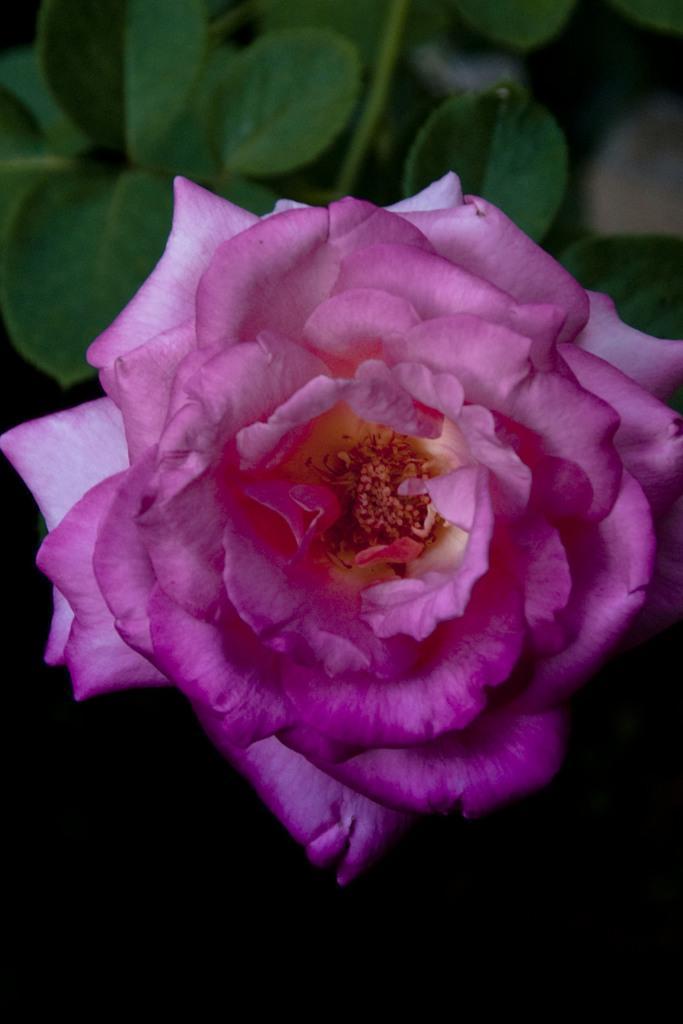Please provide a concise description of this image. In the foreground of this image, there is a pink color flower and at the top there are leaves. 